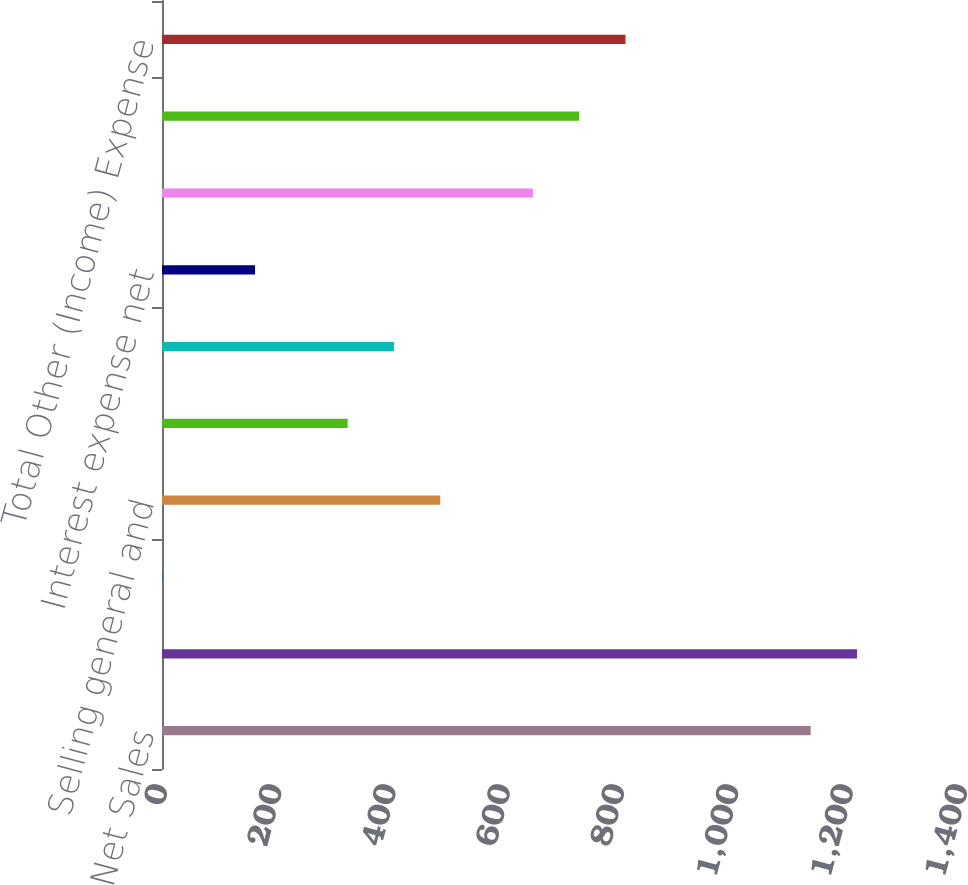Convert chart to OTSL. <chart><loc_0><loc_0><loc_500><loc_500><bar_chart><fcel>Net Sales<fcel>Cost of Sales<fcel>Gross Profit (Loss)<fcel>Selling general and<fcel>Other charges<fcel>Operating Income (Loss)<fcel>Interest expense net<fcel>Other net<fcel>Equity in net earnings of<fcel>Total Other (Income) Expense<nl><fcel>1135.14<fcel>1216.17<fcel>0.72<fcel>486.9<fcel>324.84<fcel>405.87<fcel>162.78<fcel>648.96<fcel>729.99<fcel>811.02<nl></chart> 